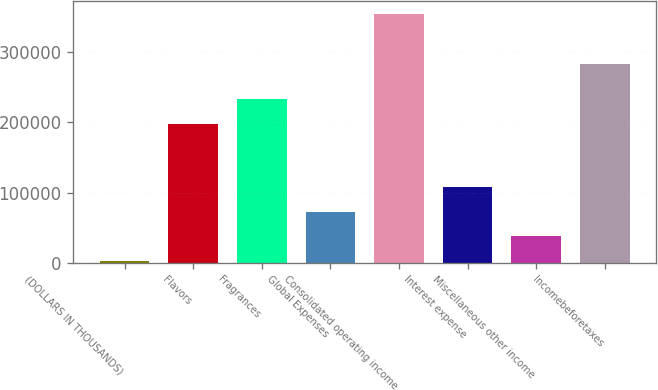Convert chart. <chart><loc_0><loc_0><loc_500><loc_500><bar_chart><fcel>(DOLLARS IN THOUSANDS)<fcel>Flavors<fcel>Fragrances<fcel>Global Expenses<fcel>Consolidated operating income<fcel>Interest expense<fcel>Miscellaneous other income<fcel>Incomebeforetaxes<nl><fcel>2008<fcel>197838<fcel>233150<fcel>72633<fcel>355133<fcel>107946<fcel>37320.5<fcel>283922<nl></chart> 